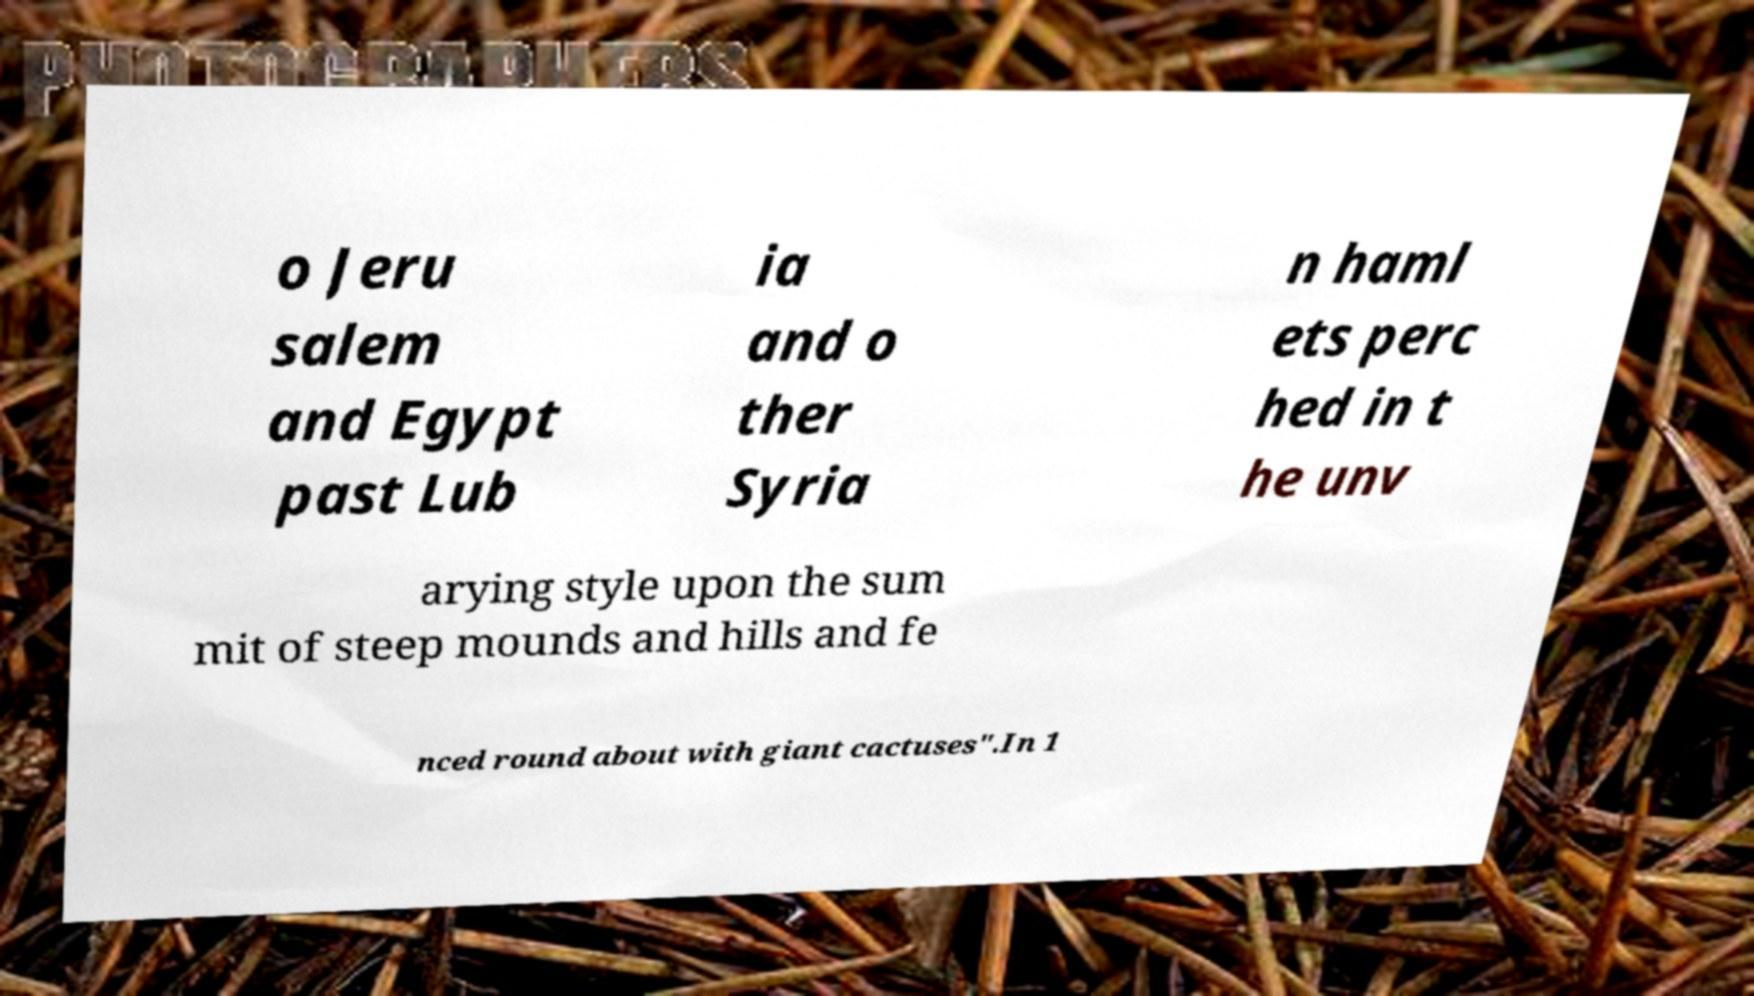Could you assist in decoding the text presented in this image and type it out clearly? o Jeru salem and Egypt past Lub ia and o ther Syria n haml ets perc hed in t he unv arying style upon the sum mit of steep mounds and hills and fe nced round about with giant cactuses".In 1 